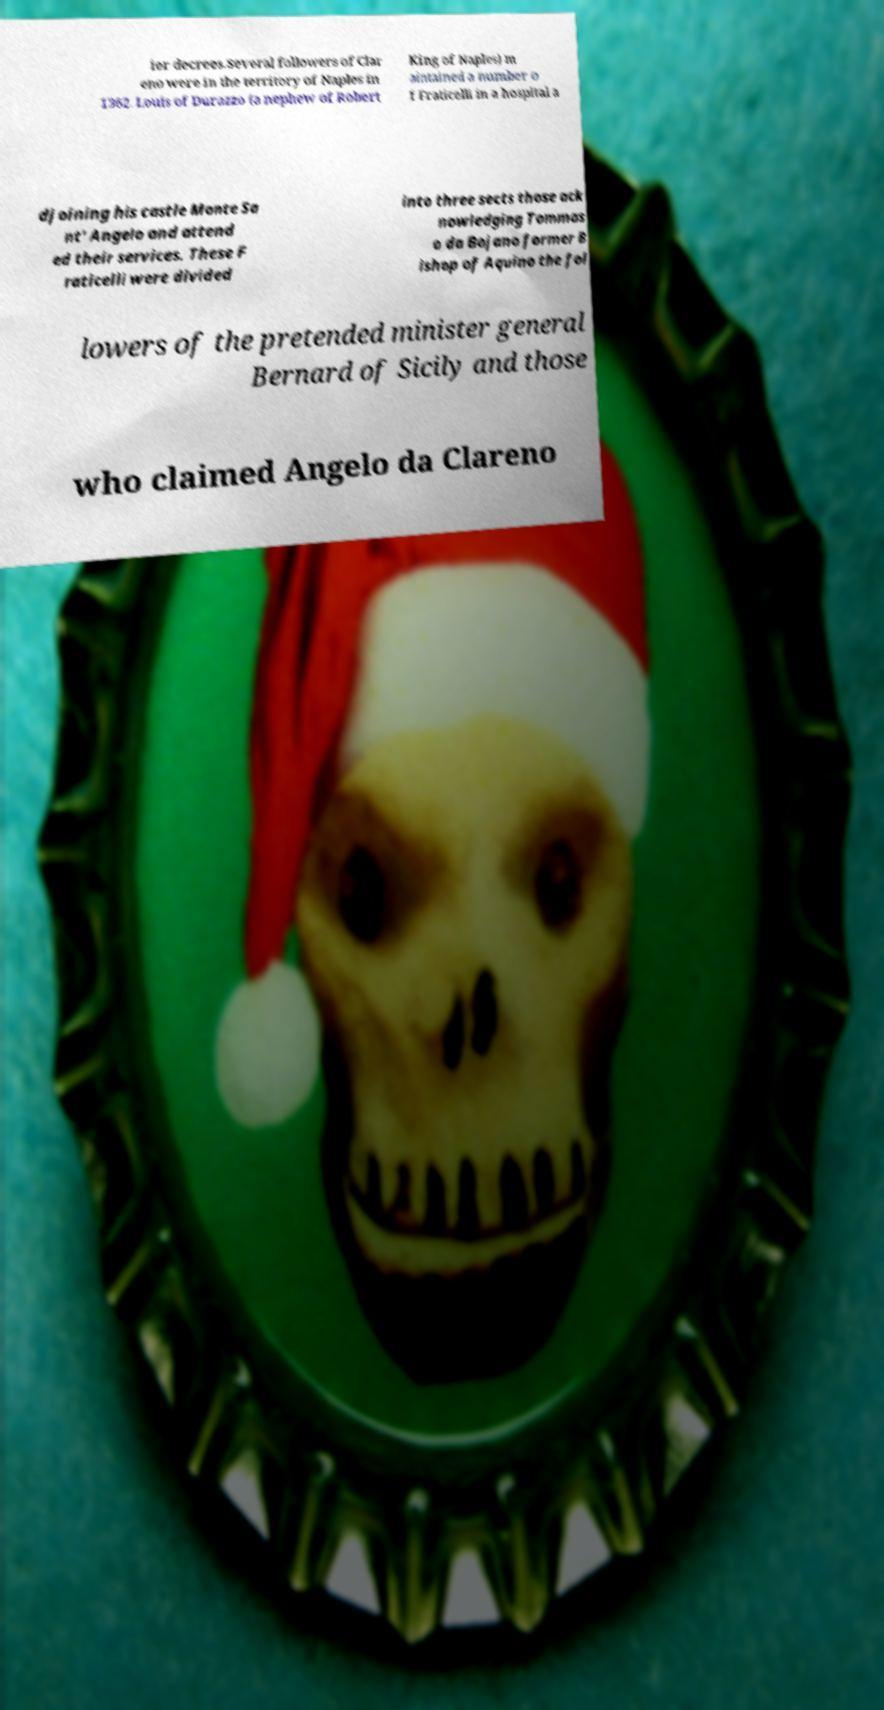For documentation purposes, I need the text within this image transcribed. Could you provide that? ier decrees.Several followers of Clar eno were in the territory of Naples in 1362. Louis of Durazzo (a nephew of Robert King of Naples) m aintained a number o f Fraticelli in a hospital a djoining his castle Monte Sa nt' Angelo and attend ed their services. These F raticelli were divided into three sects those ack nowledging Tommas o da Bojano former B ishop of Aquino the fol lowers of the pretended minister general Bernard of Sicily and those who claimed Angelo da Clareno 